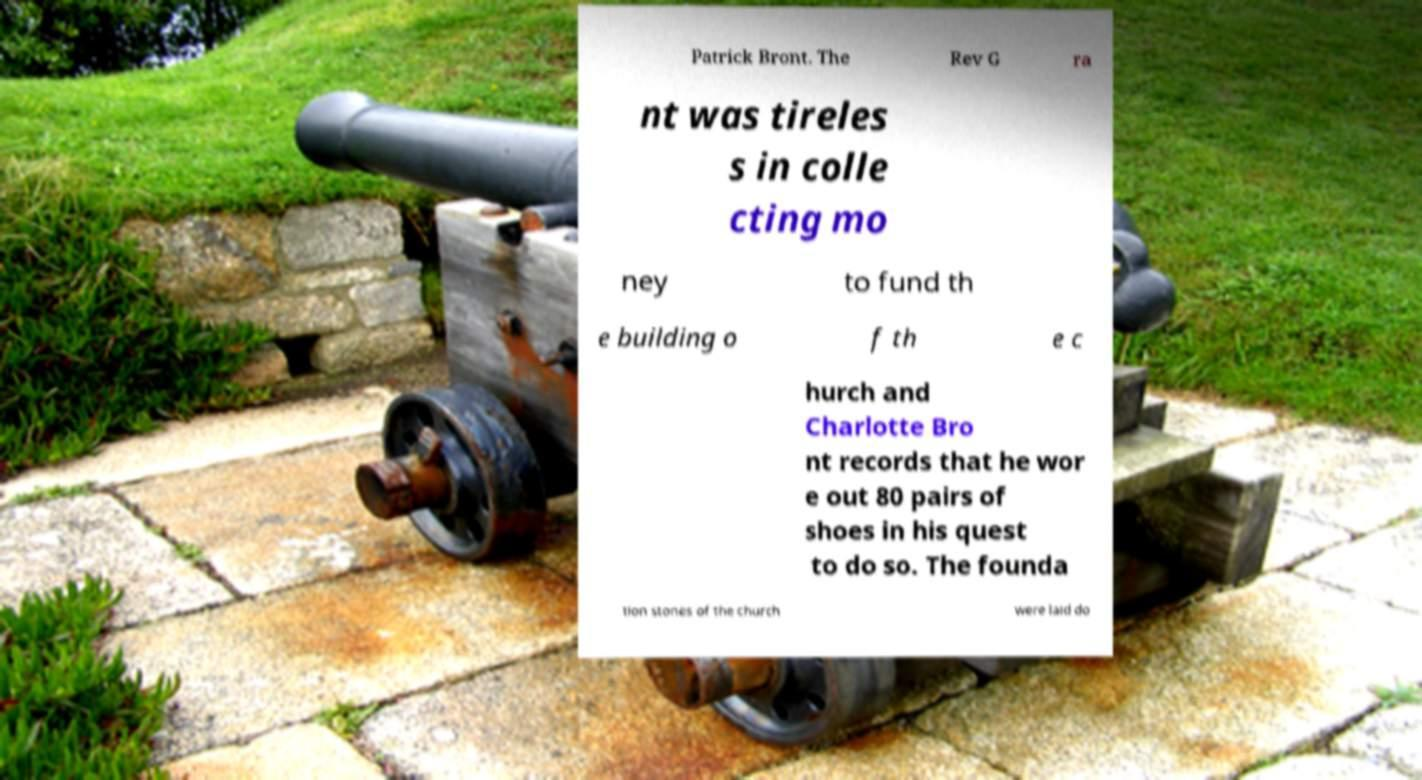I need the written content from this picture converted into text. Can you do that? Patrick Bront. The Rev G ra nt was tireles s in colle cting mo ney to fund th e building o f th e c hurch and Charlotte Bro nt records that he wor e out 80 pairs of shoes in his quest to do so. The founda tion stones of the church were laid do 